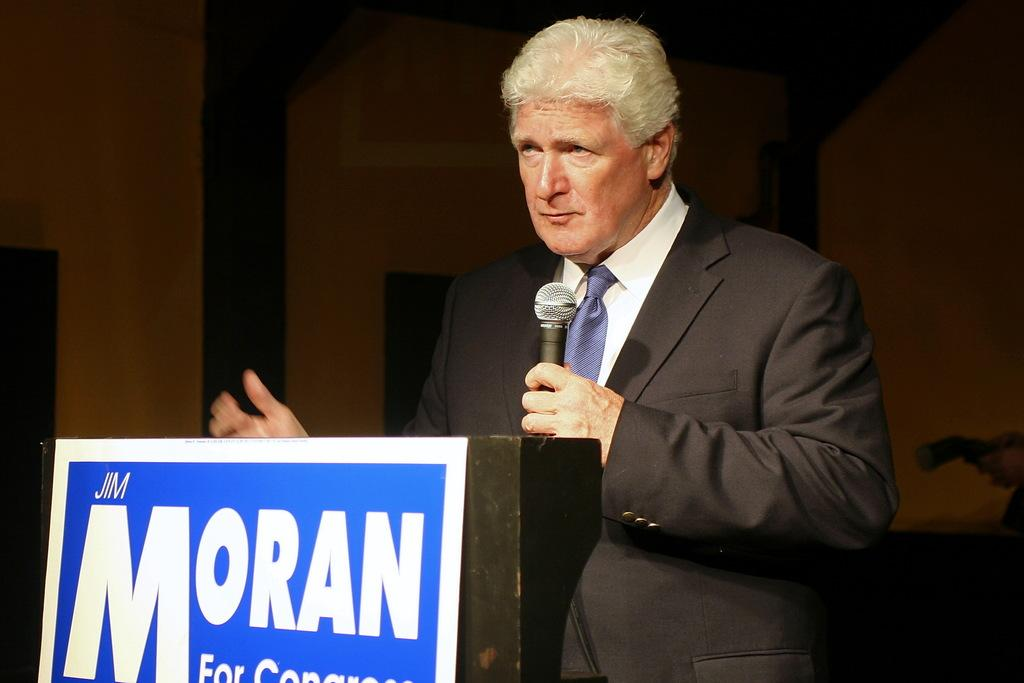Who is the main subject in the image? There is a person in the image. What is the person holding in the image? The person is holding a mic. Where is the person standing in the image? The person is standing near a podium. What is written on the board in the image? There is a board with text in the image. What can be seen in the background of the image? There is a wall in the background of the image. What type of scent can be smelled coming from the jar on the podium? There is no jar present on the podium in the image, so it is not possible to determine what scent might be smelled. 